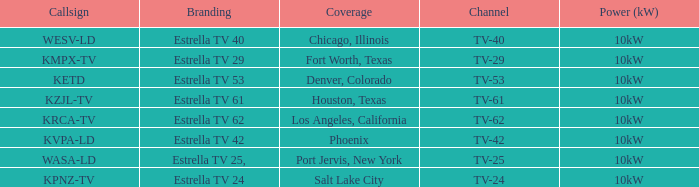List the branding for krca-tv. Estrella TV 62. 